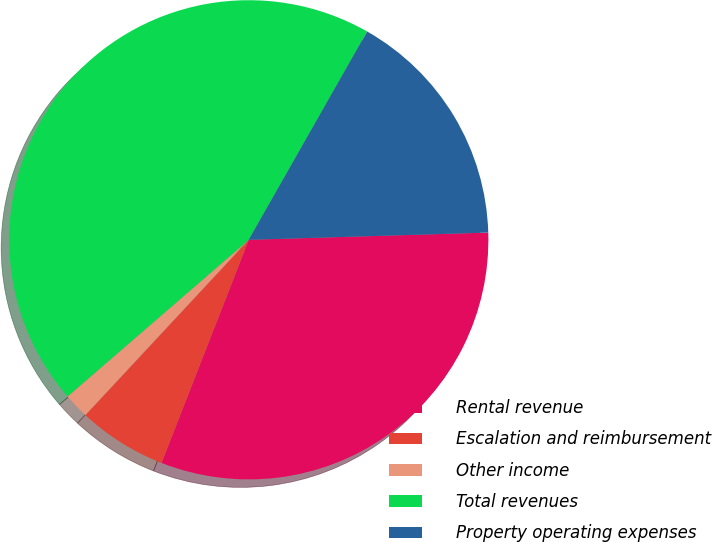Convert chart to OTSL. <chart><loc_0><loc_0><loc_500><loc_500><pie_chart><fcel>Rental revenue<fcel>Escalation and reimbursement<fcel>Other income<fcel>Total revenues<fcel>Property operating expenses<nl><fcel>31.41%<fcel>6.0%<fcel>1.72%<fcel>44.57%<fcel>16.29%<nl></chart> 